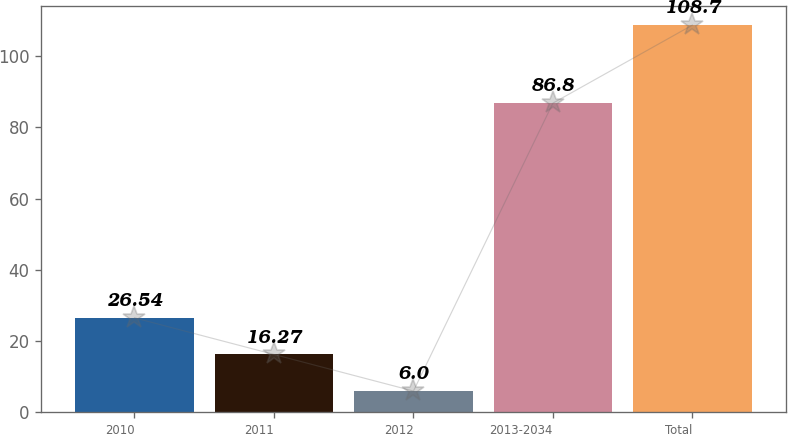Convert chart. <chart><loc_0><loc_0><loc_500><loc_500><bar_chart><fcel>2010<fcel>2011<fcel>2012<fcel>2013-2034<fcel>Total<nl><fcel>26.54<fcel>16.27<fcel>6<fcel>86.8<fcel>108.7<nl></chart> 